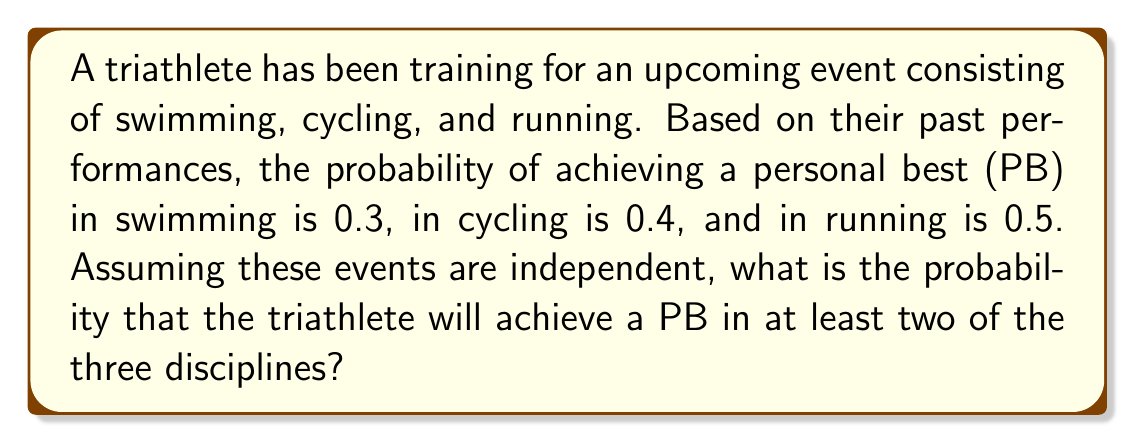Give your solution to this math problem. To solve this problem, we'll use probability theory and the concept of complementary events.

1) First, let's define our events:
   S: PB in swimming
   C: PB in cycling
   R: PB in running

2) We're given:
   P(S) = 0.3
   P(C) = 0.4
   P(R) = 0.5

3) We want to find the probability of achieving a PB in at least two disciplines. It's easier to calculate the complement of this event: the probability of achieving a PB in one or zero disciplines.

4) The probability of not achieving a PB in each discipline:
   P(not S) = 1 - 0.3 = 0.7
   P(not C) = 1 - 0.4 = 0.6
   P(not R) = 1 - 0.5 = 0.5

5) Now, we can calculate the probability of achieving no PBs:
   P(no PBs) = P(not S) × P(not C) × P(not R) = 0.7 × 0.6 × 0.5 = 0.21

6) The probability of achieving exactly one PB:
   P(only S) = 0.3 × 0.6 × 0.5 = 0.09
   P(only C) = 0.7 × 0.4 × 0.5 = 0.14
   P(only R) = 0.7 × 0.6 × 0.5 = 0.21

   P(exactly one PB) = 0.09 + 0.14 + 0.21 = 0.44

7) Therefore, the probability of achieving one or zero PBs:
   P(one or zero PBs) = 0.21 + 0.44 = 0.65

8) The probability of achieving at least two PBs is the complement of this:
   P(at least two PBs) = 1 - P(one or zero PBs) = 1 - 0.65 = 0.35

Thus, the probability of achieving a PB in at least two of the three disciplines is 0.35 or 35%.
Answer: $$0.35$$ or $$35\%$$ 